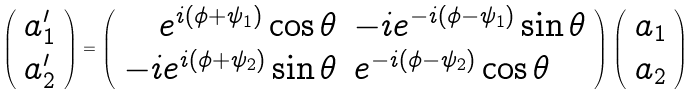Convert formula to latex. <formula><loc_0><loc_0><loc_500><loc_500>\left ( \begin{array} { c } a _ { 1 } ^ { \prime } \\ a _ { 2 } ^ { \prime } \end{array} \right ) = \left ( \begin{array} { r l } e ^ { i ( \phi + \psi _ { 1 } ) } \cos { \theta } & - i e ^ { - i ( \phi - \psi _ { 1 } ) } \sin { \theta } \\ - i e ^ { i ( \phi + \psi _ { 2 } ) } \sin { \theta } & e ^ { - i ( \phi - \psi _ { 2 } ) } \cos { \theta } \end{array} \right ) \left ( \begin{array} { c } a _ { 1 } \\ a _ { 2 } \end{array} \right )</formula> 